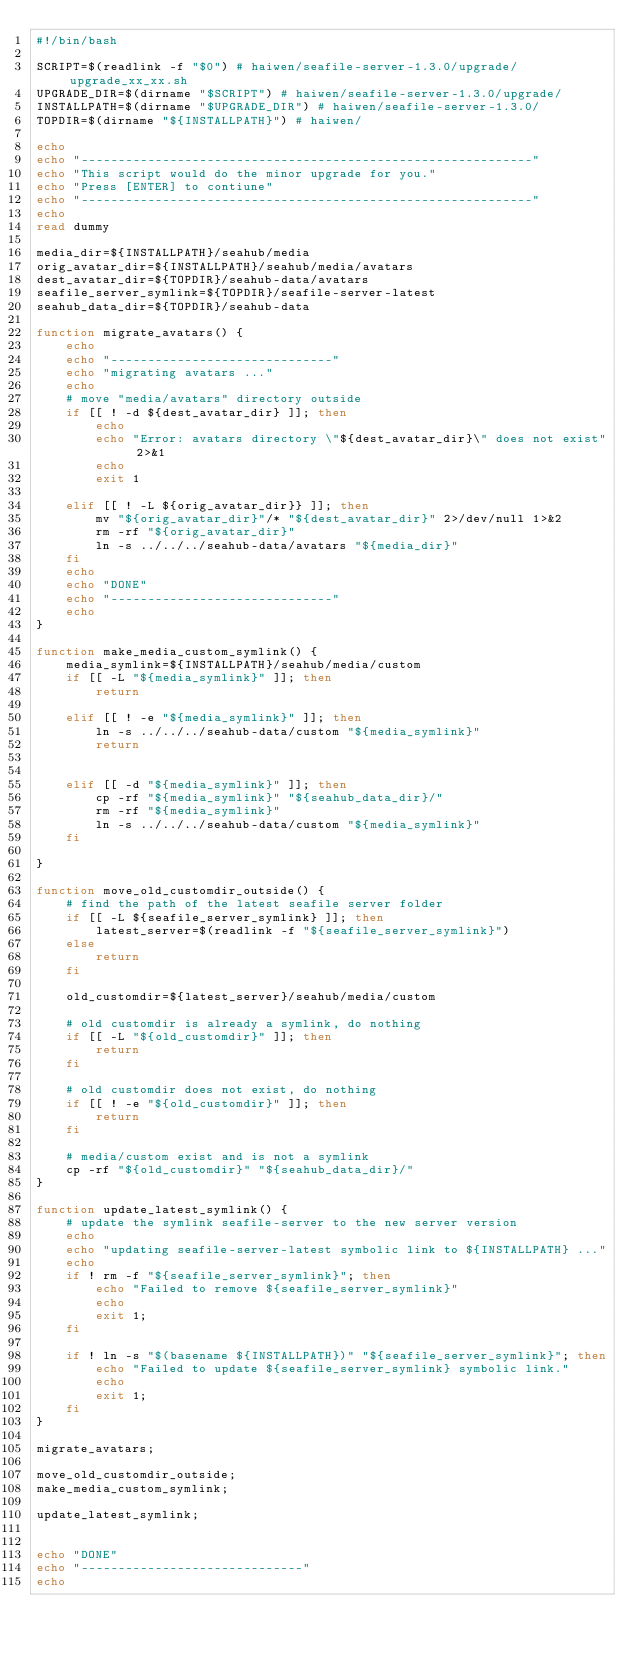Convert code to text. <code><loc_0><loc_0><loc_500><loc_500><_Bash_>#!/bin/bash

SCRIPT=$(readlink -f "$0") # haiwen/seafile-server-1.3.0/upgrade/upgrade_xx_xx.sh
UPGRADE_DIR=$(dirname "$SCRIPT") # haiwen/seafile-server-1.3.0/upgrade/
INSTALLPATH=$(dirname "$UPGRADE_DIR") # haiwen/seafile-server-1.3.0/
TOPDIR=$(dirname "${INSTALLPATH}") # haiwen/

echo
echo "-------------------------------------------------------------"
echo "This script would do the minor upgrade for you."
echo "Press [ENTER] to contiune"
echo "-------------------------------------------------------------"
echo
read dummy

media_dir=${INSTALLPATH}/seahub/media
orig_avatar_dir=${INSTALLPATH}/seahub/media/avatars
dest_avatar_dir=${TOPDIR}/seahub-data/avatars
seafile_server_symlink=${TOPDIR}/seafile-server-latest
seahub_data_dir=${TOPDIR}/seahub-data

function migrate_avatars() {
    echo
    echo "------------------------------"
    echo "migrating avatars ..."
    echo
    # move "media/avatars" directory outside
    if [[ ! -d ${dest_avatar_dir} ]]; then
        echo
        echo "Error: avatars directory \"${dest_avatar_dir}\" does not exist" 2>&1
        echo
        exit 1

    elif [[ ! -L ${orig_avatar_dir}} ]]; then
        mv "${orig_avatar_dir}"/* "${dest_avatar_dir}" 2>/dev/null 1>&2
        rm -rf "${orig_avatar_dir}"
        ln -s ../../../seahub-data/avatars "${media_dir}"
    fi
    echo
    echo "DONE"
    echo "------------------------------"
    echo
}

function make_media_custom_symlink() {
    media_symlink=${INSTALLPATH}/seahub/media/custom
    if [[ -L "${media_symlink}" ]]; then
        return

    elif [[ ! -e "${media_symlink}" ]]; then
        ln -s ../../../seahub-data/custom "${media_symlink}"
        return


    elif [[ -d "${media_symlink}" ]]; then
        cp -rf "${media_symlink}" "${seahub_data_dir}/"
        rm -rf "${media_symlink}"
        ln -s ../../../seahub-data/custom "${media_symlink}"
    fi

}

function move_old_customdir_outside() {
    # find the path of the latest seafile server folder
    if [[ -L ${seafile_server_symlink} ]]; then
        latest_server=$(readlink -f "${seafile_server_symlink}")
    else
        return
    fi

    old_customdir=${latest_server}/seahub/media/custom

    # old customdir is already a symlink, do nothing
    if [[ -L "${old_customdir}" ]]; then
        return
    fi

    # old customdir does not exist, do nothing
    if [[ ! -e "${old_customdir}" ]]; then
        return
    fi

    # media/custom exist and is not a symlink
    cp -rf "${old_customdir}" "${seahub_data_dir}/"
}

function update_latest_symlink() {
    # update the symlink seafile-server to the new server version
    echo
    echo "updating seafile-server-latest symbolic link to ${INSTALLPATH} ..."
    echo
    if ! rm -f "${seafile_server_symlink}"; then
        echo "Failed to remove ${seafile_server_symlink}"
        echo
        exit 1;
    fi

    if ! ln -s "$(basename ${INSTALLPATH})" "${seafile_server_symlink}"; then
        echo "Failed to update ${seafile_server_symlink} symbolic link."
        echo
        exit 1;
    fi
}

migrate_avatars;

move_old_customdir_outside;
make_media_custom_symlink;

update_latest_symlink;


echo "DONE"
echo "------------------------------"
echo
</code> 